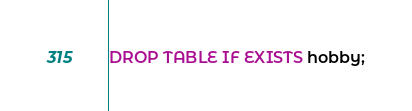Convert code to text. <code><loc_0><loc_0><loc_500><loc_500><_SQL_>DROP TABLE IF EXISTS hobby;</code> 